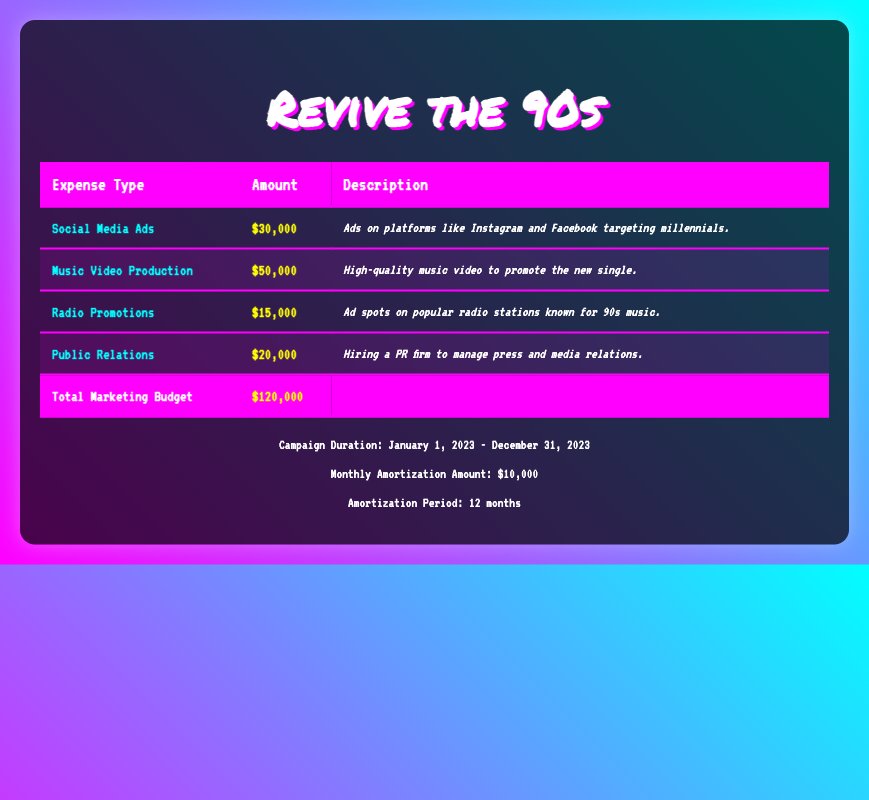What is the total marketing budget for the campaign? The total marketing budget is explicitly stated at the bottom of the table under "Total Marketing Budget", which shows $120,000.
Answer: 120000 How much is allocated for Music Video Production? The amount allocated for Music Video Production can be found in the second row of the table under "Amount", which indicates $50,000.
Answer: 50000 What is the difference between the expenses for Social Media Ads and Radio Promotions? The expense for Social Media Ads is $30,000 and the expense for Radio Promotions is $15,000. The difference is calculated as $30,000 - $15,000 = $15,000.
Answer: 15000 Is there an expense for Social Media Ads higher than $25,000? The expense for Social Media Ads is $30,000, which is indeed higher than $25,000.
Answer: Yes What is the total amount spent on Public Relations and Radio Promotions combined? The amount for Public Relations is $20,000 and for Radio Promotions it is $15,000. Adding these amounts gives $20,000 + $15,000 = $35,000.
Answer: 35000 If the campaign runs for 12 months, what is the total amortization amount for the entire campaign? The monthly amortization amount is stated as $10,000 for a duration of 12 months. Therefore, the total is $10,000 * 12 = $120,000. This matches the total marketing budget.
Answer: 120000 Is the total amount of marketing budget equally distributed among all expenses? No, the amounts for the individual expenses are not equal; they are different values (e.g., Social Media Ads: $30,000, Music Video Production: $50,000, etc.)
Answer: No What is the average monthly expense for the campaign if the total expenses are $120,000? To find the average monthly expense, divide the total expense of $120,000 by the amortization period of 12 months. The calculation is $120,000 / 12 = $10,000.
Answer: 10000 Which expense type has the highest amount allocated, and what is that amount? The highest amount allocated is for Music Video Production, which is $50,000 as noted in the second row of the table.
Answer: Music Video Production: 50000 